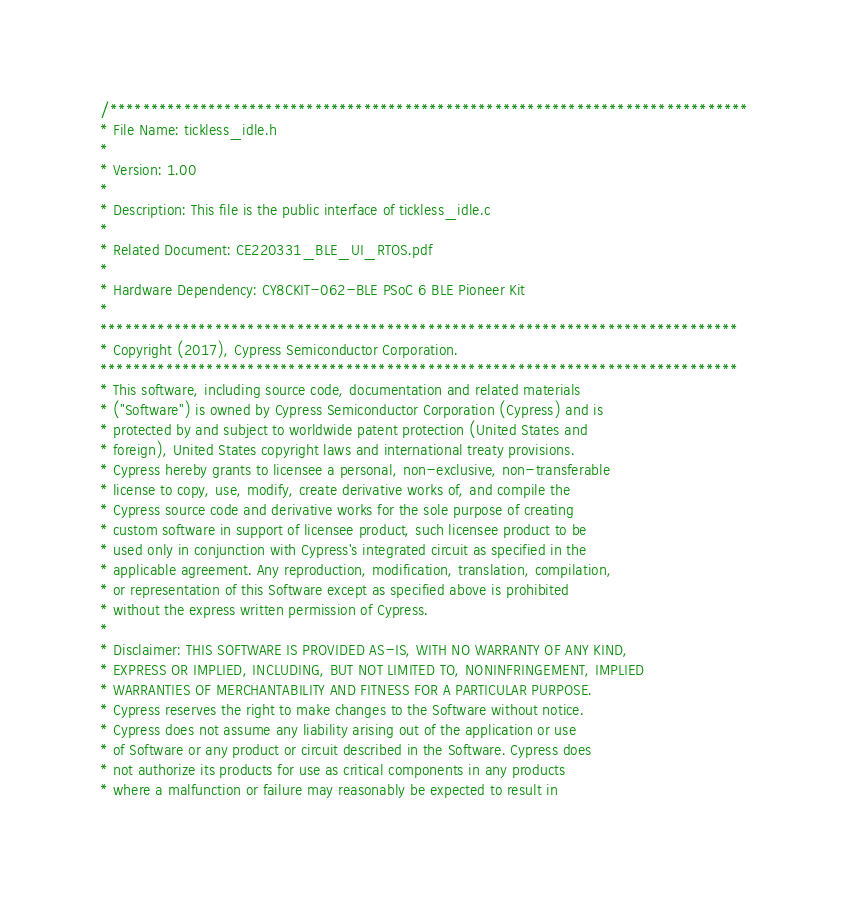Convert code to text. <code><loc_0><loc_0><loc_500><loc_500><_C_>/******************************************************************************
* File Name: tickless_idle.h
*
* Version: 1.00
*
* Description: This file is the public interface of tickless_idle.c
*
* Related Document: CE220331_BLE_UI_RTOS.pdf
*
* Hardware Dependency: CY8CKIT-062-BLE PSoC 6 BLE Pioneer Kit
*
******************************************************************************
* Copyright (2017), Cypress Semiconductor Corporation.
******************************************************************************
* This software, including source code, documentation and related materials
* ("Software") is owned by Cypress Semiconductor Corporation (Cypress) and is
* protected by and subject to worldwide patent protection (United States and 
* foreign), United States copyright laws and international treaty provisions. 
* Cypress hereby grants to licensee a personal, non-exclusive, non-transferable
* license to copy, use, modify, create derivative works of, and compile the 
* Cypress source code and derivative works for the sole purpose of creating 
* custom software in support of licensee product, such licensee product to be
* used only in conjunction with Cypress's integrated circuit as specified in the
* applicable agreement. Any reproduction, modification, translation, compilation,
* or representation of this Software except as specified above is prohibited 
* without the express written permission of Cypress.
* 
* Disclaimer: THIS SOFTWARE IS PROVIDED AS-IS, WITH NO WARRANTY OF ANY KIND, 
* EXPRESS OR IMPLIED, INCLUDING, BUT NOT LIMITED TO, NONINFRINGEMENT, IMPLIED 
* WARRANTIES OF MERCHANTABILITY AND FITNESS FOR A PARTICULAR PURPOSE.
* Cypress reserves the right to make changes to the Software without notice. 
* Cypress does not assume any liability arising out of the application or use
* of Software or any product or circuit described in the Software. Cypress does
* not authorize its products for use as critical components in any products 
* where a malfunction or failure may reasonably be expected to result in </code> 